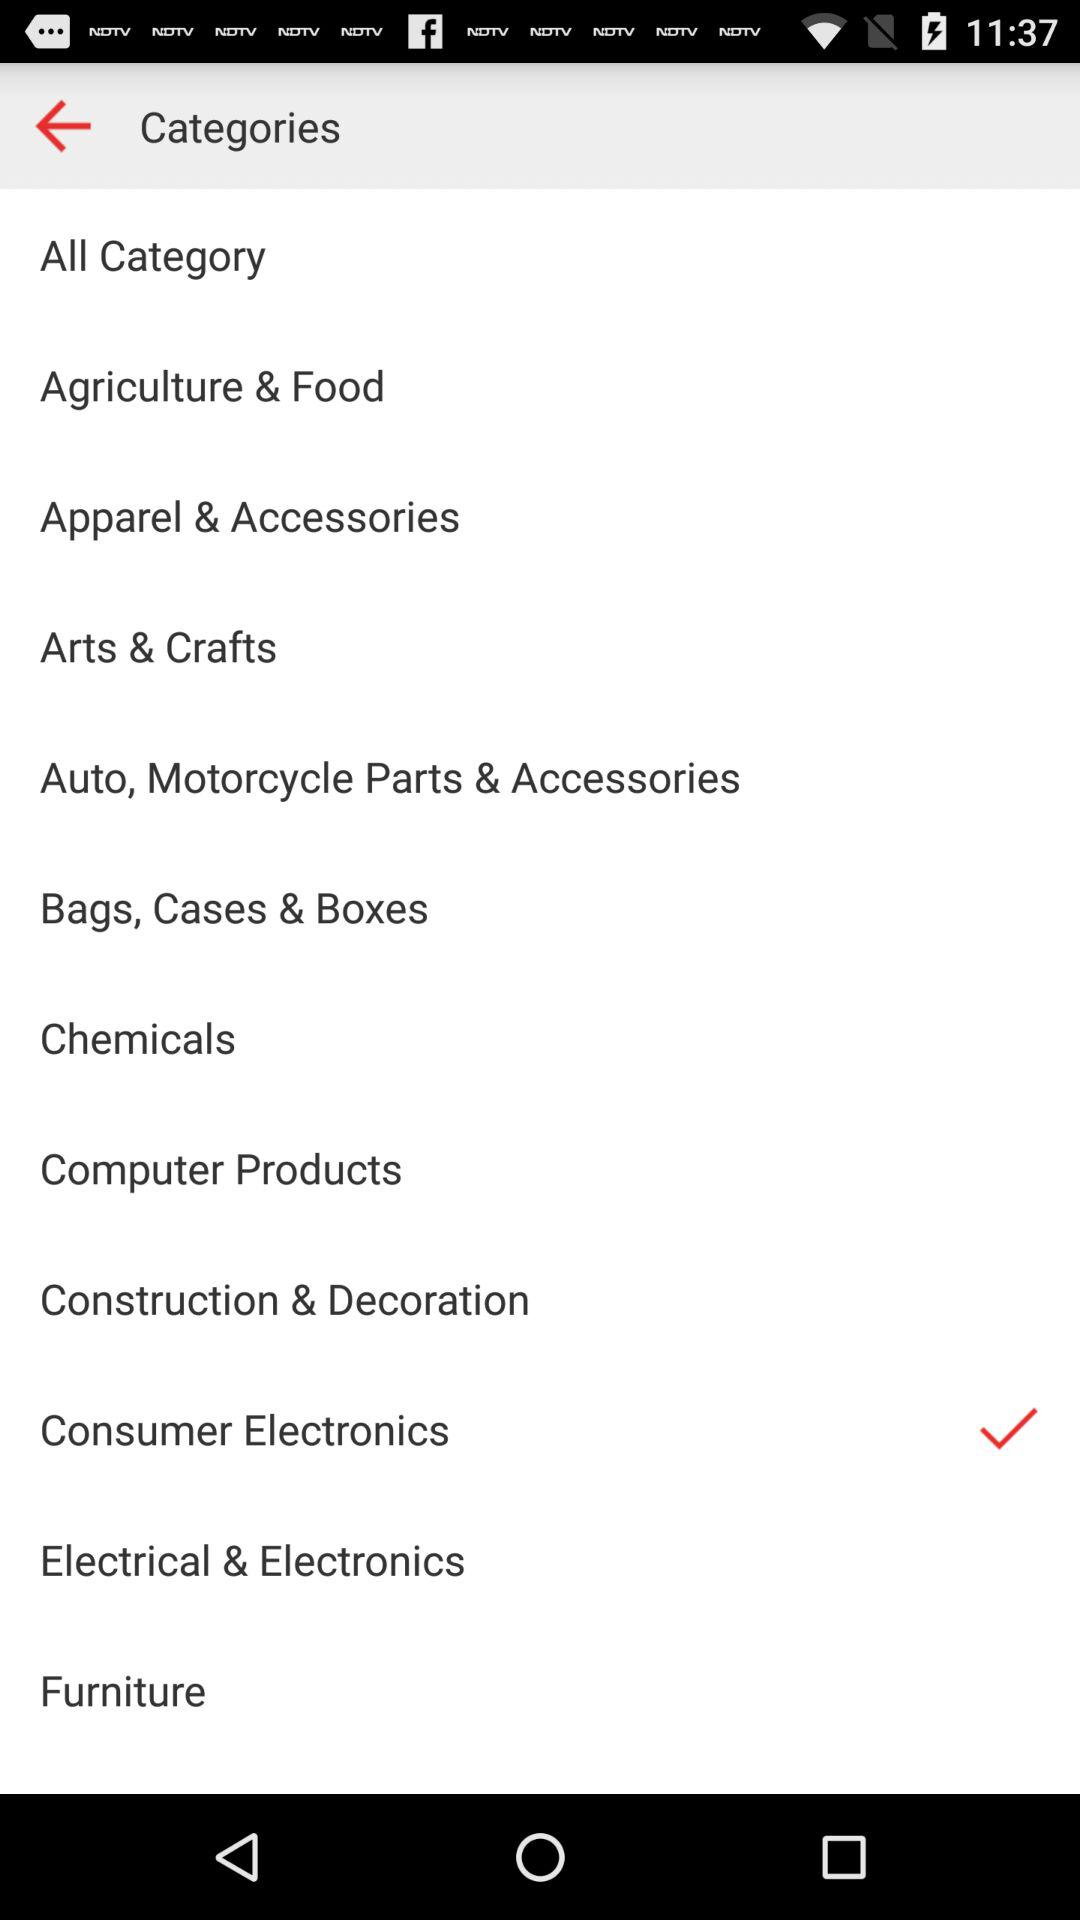How many categories have a check mark?
Answer the question using a single word or phrase. 1 